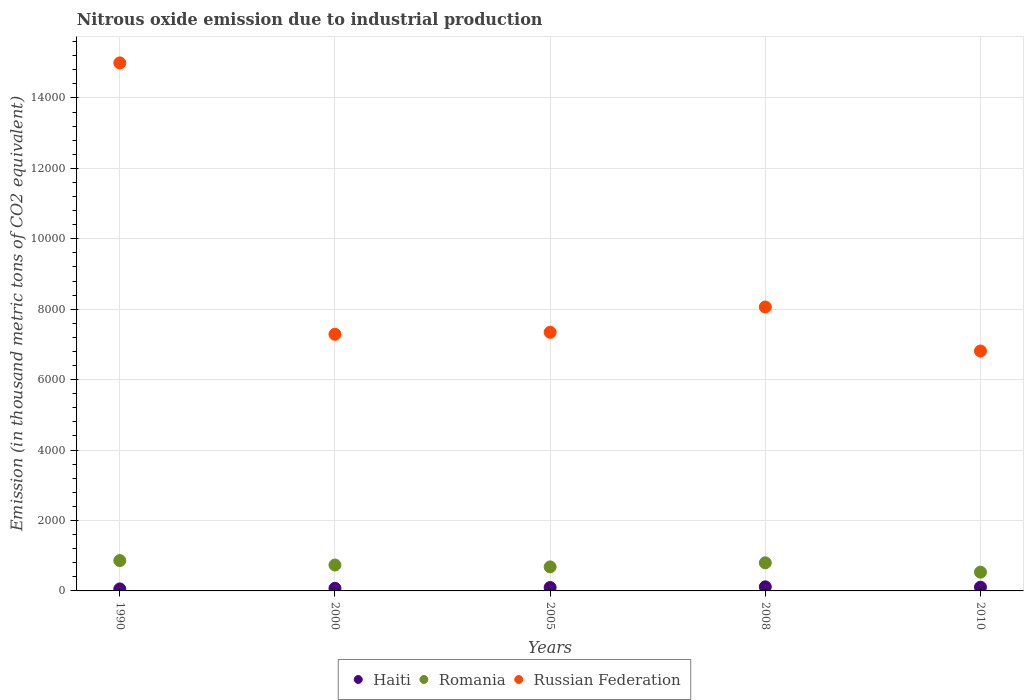How many different coloured dotlines are there?
Provide a succinct answer. 3. Is the number of dotlines equal to the number of legend labels?
Provide a short and direct response. Yes. What is the amount of nitrous oxide emitted in Haiti in 2008?
Keep it short and to the point. 116. Across all years, what is the maximum amount of nitrous oxide emitted in Romania?
Provide a short and direct response. 861.1. Across all years, what is the minimum amount of nitrous oxide emitted in Russian Federation?
Provide a short and direct response. 6812.8. In which year was the amount of nitrous oxide emitted in Haiti maximum?
Keep it short and to the point. 2008. What is the total amount of nitrous oxide emitted in Russian Federation in the graph?
Keep it short and to the point. 4.45e+04. What is the difference between the amount of nitrous oxide emitted in Russian Federation in 2005 and that in 2008?
Your response must be concise. -718.6. What is the difference between the amount of nitrous oxide emitted in Russian Federation in 1990 and the amount of nitrous oxide emitted in Haiti in 2008?
Ensure brevity in your answer.  1.49e+04. What is the average amount of nitrous oxide emitted in Russian Federation per year?
Your answer should be compact. 8900.66. In the year 2005, what is the difference between the amount of nitrous oxide emitted in Haiti and amount of nitrous oxide emitted in Russian Federation?
Your answer should be very brief. -7247.1. In how many years, is the amount of nitrous oxide emitted in Romania greater than 10000 thousand metric tons?
Offer a very short reply. 0. What is the ratio of the amount of nitrous oxide emitted in Romania in 2008 to that in 2010?
Offer a very short reply. 1.5. Is the amount of nitrous oxide emitted in Russian Federation in 2000 less than that in 2005?
Provide a short and direct response. Yes. Is the difference between the amount of nitrous oxide emitted in Haiti in 2000 and 2005 greater than the difference between the amount of nitrous oxide emitted in Russian Federation in 2000 and 2005?
Your response must be concise. Yes. What is the difference between the highest and the second highest amount of nitrous oxide emitted in Haiti?
Ensure brevity in your answer.  10.2. What is the difference between the highest and the lowest amount of nitrous oxide emitted in Romania?
Keep it short and to the point. 328.7. In how many years, is the amount of nitrous oxide emitted in Russian Federation greater than the average amount of nitrous oxide emitted in Russian Federation taken over all years?
Offer a terse response. 1. Is it the case that in every year, the sum of the amount of nitrous oxide emitted in Haiti and amount of nitrous oxide emitted in Romania  is greater than the amount of nitrous oxide emitted in Russian Federation?
Ensure brevity in your answer.  No. Does the amount of nitrous oxide emitted in Haiti monotonically increase over the years?
Your response must be concise. No. Is the amount of nitrous oxide emitted in Russian Federation strictly greater than the amount of nitrous oxide emitted in Romania over the years?
Offer a terse response. Yes. How many dotlines are there?
Offer a terse response. 3. What is the difference between two consecutive major ticks on the Y-axis?
Offer a terse response. 2000. Does the graph contain any zero values?
Provide a short and direct response. No. Where does the legend appear in the graph?
Provide a succinct answer. Bottom center. How are the legend labels stacked?
Your answer should be compact. Horizontal. What is the title of the graph?
Ensure brevity in your answer.  Nitrous oxide emission due to industrial production. Does "El Salvador" appear as one of the legend labels in the graph?
Keep it short and to the point. No. What is the label or title of the X-axis?
Provide a short and direct response. Years. What is the label or title of the Y-axis?
Make the answer very short. Emission (in thousand metric tons of CO2 equivalent). What is the Emission (in thousand metric tons of CO2 equivalent) in Haiti in 1990?
Offer a terse response. 56.6. What is the Emission (in thousand metric tons of CO2 equivalent) of Romania in 1990?
Provide a short and direct response. 861.1. What is the Emission (in thousand metric tons of CO2 equivalent) in Russian Federation in 1990?
Provide a succinct answer. 1.50e+04. What is the Emission (in thousand metric tons of CO2 equivalent) of Haiti in 2000?
Provide a short and direct response. 73.8. What is the Emission (in thousand metric tons of CO2 equivalent) in Romania in 2000?
Offer a very short reply. 735.3. What is the Emission (in thousand metric tons of CO2 equivalent) of Russian Federation in 2000?
Give a very brief answer. 7288.4. What is the Emission (in thousand metric tons of CO2 equivalent) of Haiti in 2005?
Provide a succinct answer. 97. What is the Emission (in thousand metric tons of CO2 equivalent) in Romania in 2005?
Give a very brief answer. 682.3. What is the Emission (in thousand metric tons of CO2 equivalent) in Russian Federation in 2005?
Your answer should be compact. 7344.1. What is the Emission (in thousand metric tons of CO2 equivalent) in Haiti in 2008?
Provide a short and direct response. 116. What is the Emission (in thousand metric tons of CO2 equivalent) in Romania in 2008?
Make the answer very short. 798. What is the Emission (in thousand metric tons of CO2 equivalent) of Russian Federation in 2008?
Offer a very short reply. 8062.7. What is the Emission (in thousand metric tons of CO2 equivalent) in Haiti in 2010?
Offer a very short reply. 105.8. What is the Emission (in thousand metric tons of CO2 equivalent) in Romania in 2010?
Provide a short and direct response. 532.4. What is the Emission (in thousand metric tons of CO2 equivalent) in Russian Federation in 2010?
Provide a short and direct response. 6812.8. Across all years, what is the maximum Emission (in thousand metric tons of CO2 equivalent) of Haiti?
Your response must be concise. 116. Across all years, what is the maximum Emission (in thousand metric tons of CO2 equivalent) of Romania?
Give a very brief answer. 861.1. Across all years, what is the maximum Emission (in thousand metric tons of CO2 equivalent) in Russian Federation?
Keep it short and to the point. 1.50e+04. Across all years, what is the minimum Emission (in thousand metric tons of CO2 equivalent) of Haiti?
Make the answer very short. 56.6. Across all years, what is the minimum Emission (in thousand metric tons of CO2 equivalent) of Romania?
Give a very brief answer. 532.4. Across all years, what is the minimum Emission (in thousand metric tons of CO2 equivalent) of Russian Federation?
Offer a very short reply. 6812.8. What is the total Emission (in thousand metric tons of CO2 equivalent) in Haiti in the graph?
Keep it short and to the point. 449.2. What is the total Emission (in thousand metric tons of CO2 equivalent) of Romania in the graph?
Provide a short and direct response. 3609.1. What is the total Emission (in thousand metric tons of CO2 equivalent) of Russian Federation in the graph?
Ensure brevity in your answer.  4.45e+04. What is the difference between the Emission (in thousand metric tons of CO2 equivalent) in Haiti in 1990 and that in 2000?
Give a very brief answer. -17.2. What is the difference between the Emission (in thousand metric tons of CO2 equivalent) of Romania in 1990 and that in 2000?
Your answer should be compact. 125.8. What is the difference between the Emission (in thousand metric tons of CO2 equivalent) in Russian Federation in 1990 and that in 2000?
Keep it short and to the point. 7706.9. What is the difference between the Emission (in thousand metric tons of CO2 equivalent) in Haiti in 1990 and that in 2005?
Your response must be concise. -40.4. What is the difference between the Emission (in thousand metric tons of CO2 equivalent) of Romania in 1990 and that in 2005?
Offer a terse response. 178.8. What is the difference between the Emission (in thousand metric tons of CO2 equivalent) in Russian Federation in 1990 and that in 2005?
Give a very brief answer. 7651.2. What is the difference between the Emission (in thousand metric tons of CO2 equivalent) of Haiti in 1990 and that in 2008?
Offer a terse response. -59.4. What is the difference between the Emission (in thousand metric tons of CO2 equivalent) of Romania in 1990 and that in 2008?
Give a very brief answer. 63.1. What is the difference between the Emission (in thousand metric tons of CO2 equivalent) of Russian Federation in 1990 and that in 2008?
Provide a succinct answer. 6932.6. What is the difference between the Emission (in thousand metric tons of CO2 equivalent) of Haiti in 1990 and that in 2010?
Keep it short and to the point. -49.2. What is the difference between the Emission (in thousand metric tons of CO2 equivalent) of Romania in 1990 and that in 2010?
Give a very brief answer. 328.7. What is the difference between the Emission (in thousand metric tons of CO2 equivalent) in Russian Federation in 1990 and that in 2010?
Offer a very short reply. 8182.5. What is the difference between the Emission (in thousand metric tons of CO2 equivalent) of Haiti in 2000 and that in 2005?
Your answer should be compact. -23.2. What is the difference between the Emission (in thousand metric tons of CO2 equivalent) of Russian Federation in 2000 and that in 2005?
Your response must be concise. -55.7. What is the difference between the Emission (in thousand metric tons of CO2 equivalent) in Haiti in 2000 and that in 2008?
Make the answer very short. -42.2. What is the difference between the Emission (in thousand metric tons of CO2 equivalent) in Romania in 2000 and that in 2008?
Offer a terse response. -62.7. What is the difference between the Emission (in thousand metric tons of CO2 equivalent) of Russian Federation in 2000 and that in 2008?
Your response must be concise. -774.3. What is the difference between the Emission (in thousand metric tons of CO2 equivalent) of Haiti in 2000 and that in 2010?
Offer a terse response. -32. What is the difference between the Emission (in thousand metric tons of CO2 equivalent) in Romania in 2000 and that in 2010?
Give a very brief answer. 202.9. What is the difference between the Emission (in thousand metric tons of CO2 equivalent) of Russian Federation in 2000 and that in 2010?
Keep it short and to the point. 475.6. What is the difference between the Emission (in thousand metric tons of CO2 equivalent) in Romania in 2005 and that in 2008?
Offer a very short reply. -115.7. What is the difference between the Emission (in thousand metric tons of CO2 equivalent) of Russian Federation in 2005 and that in 2008?
Keep it short and to the point. -718.6. What is the difference between the Emission (in thousand metric tons of CO2 equivalent) in Romania in 2005 and that in 2010?
Your answer should be very brief. 149.9. What is the difference between the Emission (in thousand metric tons of CO2 equivalent) in Russian Federation in 2005 and that in 2010?
Offer a very short reply. 531.3. What is the difference between the Emission (in thousand metric tons of CO2 equivalent) of Haiti in 2008 and that in 2010?
Provide a short and direct response. 10.2. What is the difference between the Emission (in thousand metric tons of CO2 equivalent) in Romania in 2008 and that in 2010?
Give a very brief answer. 265.6. What is the difference between the Emission (in thousand metric tons of CO2 equivalent) in Russian Federation in 2008 and that in 2010?
Ensure brevity in your answer.  1249.9. What is the difference between the Emission (in thousand metric tons of CO2 equivalent) of Haiti in 1990 and the Emission (in thousand metric tons of CO2 equivalent) of Romania in 2000?
Offer a very short reply. -678.7. What is the difference between the Emission (in thousand metric tons of CO2 equivalent) in Haiti in 1990 and the Emission (in thousand metric tons of CO2 equivalent) in Russian Federation in 2000?
Provide a succinct answer. -7231.8. What is the difference between the Emission (in thousand metric tons of CO2 equivalent) of Romania in 1990 and the Emission (in thousand metric tons of CO2 equivalent) of Russian Federation in 2000?
Your answer should be compact. -6427.3. What is the difference between the Emission (in thousand metric tons of CO2 equivalent) in Haiti in 1990 and the Emission (in thousand metric tons of CO2 equivalent) in Romania in 2005?
Your answer should be compact. -625.7. What is the difference between the Emission (in thousand metric tons of CO2 equivalent) of Haiti in 1990 and the Emission (in thousand metric tons of CO2 equivalent) of Russian Federation in 2005?
Your answer should be compact. -7287.5. What is the difference between the Emission (in thousand metric tons of CO2 equivalent) of Romania in 1990 and the Emission (in thousand metric tons of CO2 equivalent) of Russian Federation in 2005?
Give a very brief answer. -6483. What is the difference between the Emission (in thousand metric tons of CO2 equivalent) of Haiti in 1990 and the Emission (in thousand metric tons of CO2 equivalent) of Romania in 2008?
Provide a succinct answer. -741.4. What is the difference between the Emission (in thousand metric tons of CO2 equivalent) of Haiti in 1990 and the Emission (in thousand metric tons of CO2 equivalent) of Russian Federation in 2008?
Make the answer very short. -8006.1. What is the difference between the Emission (in thousand metric tons of CO2 equivalent) of Romania in 1990 and the Emission (in thousand metric tons of CO2 equivalent) of Russian Federation in 2008?
Your answer should be compact. -7201.6. What is the difference between the Emission (in thousand metric tons of CO2 equivalent) in Haiti in 1990 and the Emission (in thousand metric tons of CO2 equivalent) in Romania in 2010?
Provide a short and direct response. -475.8. What is the difference between the Emission (in thousand metric tons of CO2 equivalent) of Haiti in 1990 and the Emission (in thousand metric tons of CO2 equivalent) of Russian Federation in 2010?
Your answer should be compact. -6756.2. What is the difference between the Emission (in thousand metric tons of CO2 equivalent) of Romania in 1990 and the Emission (in thousand metric tons of CO2 equivalent) of Russian Federation in 2010?
Offer a terse response. -5951.7. What is the difference between the Emission (in thousand metric tons of CO2 equivalent) of Haiti in 2000 and the Emission (in thousand metric tons of CO2 equivalent) of Romania in 2005?
Provide a short and direct response. -608.5. What is the difference between the Emission (in thousand metric tons of CO2 equivalent) of Haiti in 2000 and the Emission (in thousand metric tons of CO2 equivalent) of Russian Federation in 2005?
Keep it short and to the point. -7270.3. What is the difference between the Emission (in thousand metric tons of CO2 equivalent) in Romania in 2000 and the Emission (in thousand metric tons of CO2 equivalent) in Russian Federation in 2005?
Offer a very short reply. -6608.8. What is the difference between the Emission (in thousand metric tons of CO2 equivalent) in Haiti in 2000 and the Emission (in thousand metric tons of CO2 equivalent) in Romania in 2008?
Keep it short and to the point. -724.2. What is the difference between the Emission (in thousand metric tons of CO2 equivalent) of Haiti in 2000 and the Emission (in thousand metric tons of CO2 equivalent) of Russian Federation in 2008?
Offer a terse response. -7988.9. What is the difference between the Emission (in thousand metric tons of CO2 equivalent) of Romania in 2000 and the Emission (in thousand metric tons of CO2 equivalent) of Russian Federation in 2008?
Your response must be concise. -7327.4. What is the difference between the Emission (in thousand metric tons of CO2 equivalent) of Haiti in 2000 and the Emission (in thousand metric tons of CO2 equivalent) of Romania in 2010?
Your response must be concise. -458.6. What is the difference between the Emission (in thousand metric tons of CO2 equivalent) in Haiti in 2000 and the Emission (in thousand metric tons of CO2 equivalent) in Russian Federation in 2010?
Provide a short and direct response. -6739. What is the difference between the Emission (in thousand metric tons of CO2 equivalent) in Romania in 2000 and the Emission (in thousand metric tons of CO2 equivalent) in Russian Federation in 2010?
Make the answer very short. -6077.5. What is the difference between the Emission (in thousand metric tons of CO2 equivalent) of Haiti in 2005 and the Emission (in thousand metric tons of CO2 equivalent) of Romania in 2008?
Offer a very short reply. -701. What is the difference between the Emission (in thousand metric tons of CO2 equivalent) in Haiti in 2005 and the Emission (in thousand metric tons of CO2 equivalent) in Russian Federation in 2008?
Give a very brief answer. -7965.7. What is the difference between the Emission (in thousand metric tons of CO2 equivalent) of Romania in 2005 and the Emission (in thousand metric tons of CO2 equivalent) of Russian Federation in 2008?
Provide a short and direct response. -7380.4. What is the difference between the Emission (in thousand metric tons of CO2 equivalent) in Haiti in 2005 and the Emission (in thousand metric tons of CO2 equivalent) in Romania in 2010?
Keep it short and to the point. -435.4. What is the difference between the Emission (in thousand metric tons of CO2 equivalent) of Haiti in 2005 and the Emission (in thousand metric tons of CO2 equivalent) of Russian Federation in 2010?
Give a very brief answer. -6715.8. What is the difference between the Emission (in thousand metric tons of CO2 equivalent) of Romania in 2005 and the Emission (in thousand metric tons of CO2 equivalent) of Russian Federation in 2010?
Ensure brevity in your answer.  -6130.5. What is the difference between the Emission (in thousand metric tons of CO2 equivalent) of Haiti in 2008 and the Emission (in thousand metric tons of CO2 equivalent) of Romania in 2010?
Make the answer very short. -416.4. What is the difference between the Emission (in thousand metric tons of CO2 equivalent) of Haiti in 2008 and the Emission (in thousand metric tons of CO2 equivalent) of Russian Federation in 2010?
Your answer should be very brief. -6696.8. What is the difference between the Emission (in thousand metric tons of CO2 equivalent) of Romania in 2008 and the Emission (in thousand metric tons of CO2 equivalent) of Russian Federation in 2010?
Your answer should be compact. -6014.8. What is the average Emission (in thousand metric tons of CO2 equivalent) of Haiti per year?
Provide a succinct answer. 89.84. What is the average Emission (in thousand metric tons of CO2 equivalent) of Romania per year?
Make the answer very short. 721.82. What is the average Emission (in thousand metric tons of CO2 equivalent) in Russian Federation per year?
Make the answer very short. 8900.66. In the year 1990, what is the difference between the Emission (in thousand metric tons of CO2 equivalent) of Haiti and Emission (in thousand metric tons of CO2 equivalent) of Romania?
Make the answer very short. -804.5. In the year 1990, what is the difference between the Emission (in thousand metric tons of CO2 equivalent) in Haiti and Emission (in thousand metric tons of CO2 equivalent) in Russian Federation?
Ensure brevity in your answer.  -1.49e+04. In the year 1990, what is the difference between the Emission (in thousand metric tons of CO2 equivalent) in Romania and Emission (in thousand metric tons of CO2 equivalent) in Russian Federation?
Offer a very short reply. -1.41e+04. In the year 2000, what is the difference between the Emission (in thousand metric tons of CO2 equivalent) of Haiti and Emission (in thousand metric tons of CO2 equivalent) of Romania?
Offer a very short reply. -661.5. In the year 2000, what is the difference between the Emission (in thousand metric tons of CO2 equivalent) of Haiti and Emission (in thousand metric tons of CO2 equivalent) of Russian Federation?
Make the answer very short. -7214.6. In the year 2000, what is the difference between the Emission (in thousand metric tons of CO2 equivalent) in Romania and Emission (in thousand metric tons of CO2 equivalent) in Russian Federation?
Offer a very short reply. -6553.1. In the year 2005, what is the difference between the Emission (in thousand metric tons of CO2 equivalent) in Haiti and Emission (in thousand metric tons of CO2 equivalent) in Romania?
Your answer should be compact. -585.3. In the year 2005, what is the difference between the Emission (in thousand metric tons of CO2 equivalent) in Haiti and Emission (in thousand metric tons of CO2 equivalent) in Russian Federation?
Ensure brevity in your answer.  -7247.1. In the year 2005, what is the difference between the Emission (in thousand metric tons of CO2 equivalent) in Romania and Emission (in thousand metric tons of CO2 equivalent) in Russian Federation?
Your answer should be very brief. -6661.8. In the year 2008, what is the difference between the Emission (in thousand metric tons of CO2 equivalent) in Haiti and Emission (in thousand metric tons of CO2 equivalent) in Romania?
Offer a terse response. -682. In the year 2008, what is the difference between the Emission (in thousand metric tons of CO2 equivalent) of Haiti and Emission (in thousand metric tons of CO2 equivalent) of Russian Federation?
Give a very brief answer. -7946.7. In the year 2008, what is the difference between the Emission (in thousand metric tons of CO2 equivalent) in Romania and Emission (in thousand metric tons of CO2 equivalent) in Russian Federation?
Your answer should be compact. -7264.7. In the year 2010, what is the difference between the Emission (in thousand metric tons of CO2 equivalent) of Haiti and Emission (in thousand metric tons of CO2 equivalent) of Romania?
Keep it short and to the point. -426.6. In the year 2010, what is the difference between the Emission (in thousand metric tons of CO2 equivalent) of Haiti and Emission (in thousand metric tons of CO2 equivalent) of Russian Federation?
Ensure brevity in your answer.  -6707. In the year 2010, what is the difference between the Emission (in thousand metric tons of CO2 equivalent) in Romania and Emission (in thousand metric tons of CO2 equivalent) in Russian Federation?
Keep it short and to the point. -6280.4. What is the ratio of the Emission (in thousand metric tons of CO2 equivalent) of Haiti in 1990 to that in 2000?
Your answer should be compact. 0.77. What is the ratio of the Emission (in thousand metric tons of CO2 equivalent) in Romania in 1990 to that in 2000?
Your answer should be very brief. 1.17. What is the ratio of the Emission (in thousand metric tons of CO2 equivalent) in Russian Federation in 1990 to that in 2000?
Ensure brevity in your answer.  2.06. What is the ratio of the Emission (in thousand metric tons of CO2 equivalent) of Haiti in 1990 to that in 2005?
Offer a very short reply. 0.58. What is the ratio of the Emission (in thousand metric tons of CO2 equivalent) in Romania in 1990 to that in 2005?
Keep it short and to the point. 1.26. What is the ratio of the Emission (in thousand metric tons of CO2 equivalent) in Russian Federation in 1990 to that in 2005?
Provide a short and direct response. 2.04. What is the ratio of the Emission (in thousand metric tons of CO2 equivalent) in Haiti in 1990 to that in 2008?
Offer a very short reply. 0.49. What is the ratio of the Emission (in thousand metric tons of CO2 equivalent) in Romania in 1990 to that in 2008?
Make the answer very short. 1.08. What is the ratio of the Emission (in thousand metric tons of CO2 equivalent) of Russian Federation in 1990 to that in 2008?
Your answer should be compact. 1.86. What is the ratio of the Emission (in thousand metric tons of CO2 equivalent) of Haiti in 1990 to that in 2010?
Your response must be concise. 0.54. What is the ratio of the Emission (in thousand metric tons of CO2 equivalent) of Romania in 1990 to that in 2010?
Your answer should be very brief. 1.62. What is the ratio of the Emission (in thousand metric tons of CO2 equivalent) of Russian Federation in 1990 to that in 2010?
Offer a terse response. 2.2. What is the ratio of the Emission (in thousand metric tons of CO2 equivalent) in Haiti in 2000 to that in 2005?
Give a very brief answer. 0.76. What is the ratio of the Emission (in thousand metric tons of CO2 equivalent) in Romania in 2000 to that in 2005?
Offer a very short reply. 1.08. What is the ratio of the Emission (in thousand metric tons of CO2 equivalent) of Russian Federation in 2000 to that in 2005?
Keep it short and to the point. 0.99. What is the ratio of the Emission (in thousand metric tons of CO2 equivalent) of Haiti in 2000 to that in 2008?
Your answer should be compact. 0.64. What is the ratio of the Emission (in thousand metric tons of CO2 equivalent) of Romania in 2000 to that in 2008?
Your answer should be very brief. 0.92. What is the ratio of the Emission (in thousand metric tons of CO2 equivalent) of Russian Federation in 2000 to that in 2008?
Offer a very short reply. 0.9. What is the ratio of the Emission (in thousand metric tons of CO2 equivalent) in Haiti in 2000 to that in 2010?
Your answer should be very brief. 0.7. What is the ratio of the Emission (in thousand metric tons of CO2 equivalent) in Romania in 2000 to that in 2010?
Your response must be concise. 1.38. What is the ratio of the Emission (in thousand metric tons of CO2 equivalent) in Russian Federation in 2000 to that in 2010?
Ensure brevity in your answer.  1.07. What is the ratio of the Emission (in thousand metric tons of CO2 equivalent) in Haiti in 2005 to that in 2008?
Provide a short and direct response. 0.84. What is the ratio of the Emission (in thousand metric tons of CO2 equivalent) in Romania in 2005 to that in 2008?
Your answer should be compact. 0.85. What is the ratio of the Emission (in thousand metric tons of CO2 equivalent) of Russian Federation in 2005 to that in 2008?
Keep it short and to the point. 0.91. What is the ratio of the Emission (in thousand metric tons of CO2 equivalent) in Haiti in 2005 to that in 2010?
Provide a succinct answer. 0.92. What is the ratio of the Emission (in thousand metric tons of CO2 equivalent) in Romania in 2005 to that in 2010?
Your response must be concise. 1.28. What is the ratio of the Emission (in thousand metric tons of CO2 equivalent) of Russian Federation in 2005 to that in 2010?
Ensure brevity in your answer.  1.08. What is the ratio of the Emission (in thousand metric tons of CO2 equivalent) of Haiti in 2008 to that in 2010?
Offer a very short reply. 1.1. What is the ratio of the Emission (in thousand metric tons of CO2 equivalent) in Romania in 2008 to that in 2010?
Your response must be concise. 1.5. What is the ratio of the Emission (in thousand metric tons of CO2 equivalent) in Russian Federation in 2008 to that in 2010?
Give a very brief answer. 1.18. What is the difference between the highest and the second highest Emission (in thousand metric tons of CO2 equivalent) in Romania?
Offer a terse response. 63.1. What is the difference between the highest and the second highest Emission (in thousand metric tons of CO2 equivalent) of Russian Federation?
Keep it short and to the point. 6932.6. What is the difference between the highest and the lowest Emission (in thousand metric tons of CO2 equivalent) in Haiti?
Offer a terse response. 59.4. What is the difference between the highest and the lowest Emission (in thousand metric tons of CO2 equivalent) of Romania?
Your response must be concise. 328.7. What is the difference between the highest and the lowest Emission (in thousand metric tons of CO2 equivalent) of Russian Federation?
Offer a very short reply. 8182.5. 